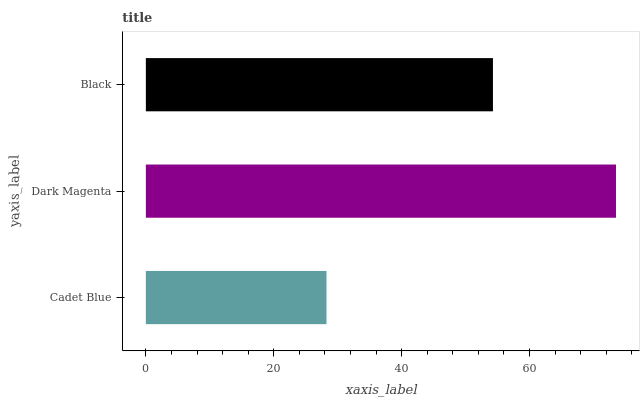Is Cadet Blue the minimum?
Answer yes or no. Yes. Is Dark Magenta the maximum?
Answer yes or no. Yes. Is Black the minimum?
Answer yes or no. No. Is Black the maximum?
Answer yes or no. No. Is Dark Magenta greater than Black?
Answer yes or no. Yes. Is Black less than Dark Magenta?
Answer yes or no. Yes. Is Black greater than Dark Magenta?
Answer yes or no. No. Is Dark Magenta less than Black?
Answer yes or no. No. Is Black the high median?
Answer yes or no. Yes. Is Black the low median?
Answer yes or no. Yes. Is Dark Magenta the high median?
Answer yes or no. No. Is Cadet Blue the low median?
Answer yes or no. No. 